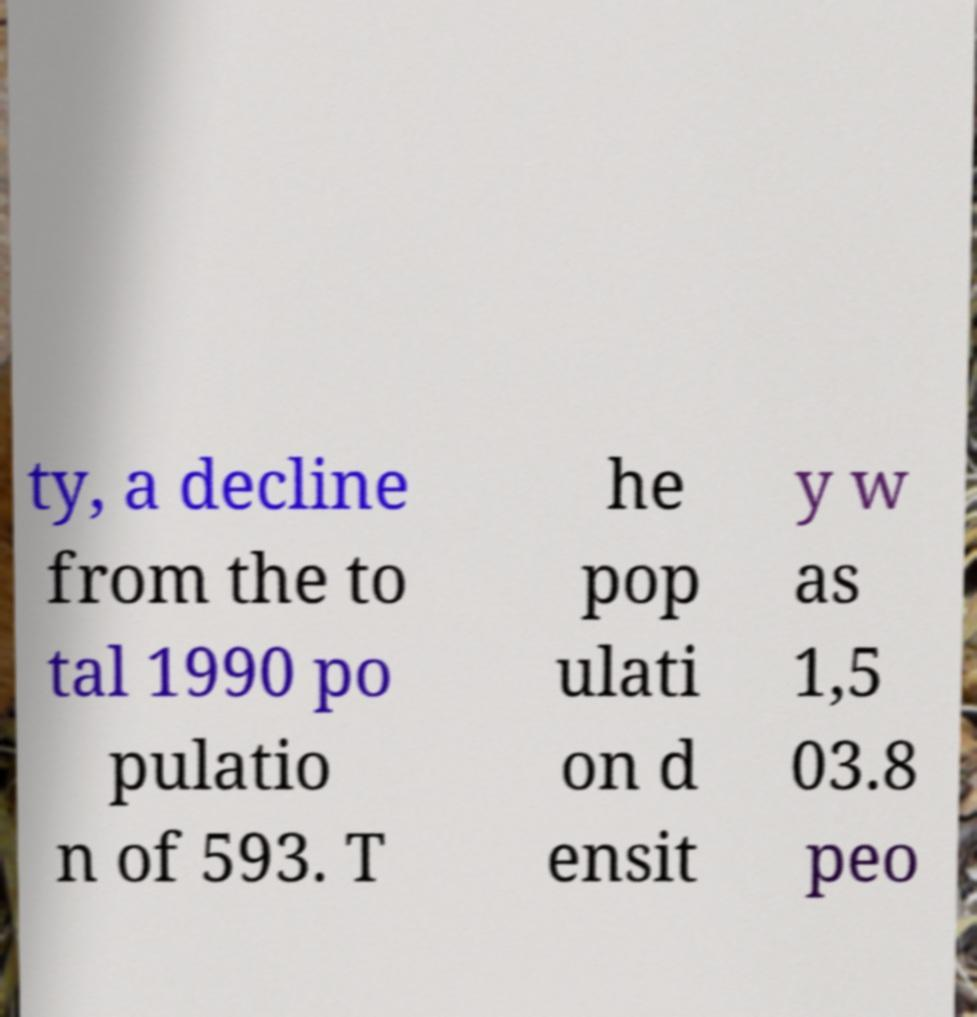Please identify and transcribe the text found in this image. ty, a decline from the to tal 1990 po pulatio n of 593. T he pop ulati on d ensit y w as 1,5 03.8 peo 